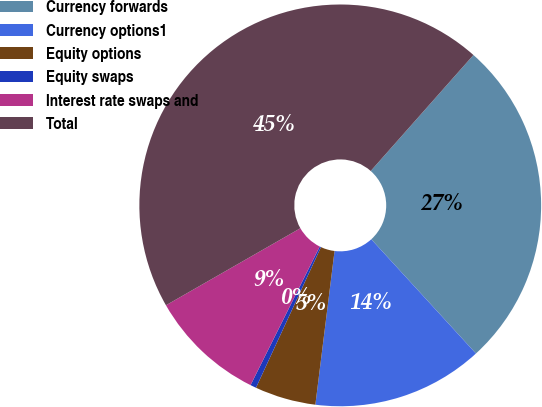Convert chart to OTSL. <chart><loc_0><loc_0><loc_500><loc_500><pie_chart><fcel>Currency forwards<fcel>Currency options1<fcel>Equity options<fcel>Equity swaps<fcel>Interest rate swaps and<fcel>Total<nl><fcel>26.66%<fcel>13.78%<fcel>4.91%<fcel>0.48%<fcel>9.35%<fcel>44.82%<nl></chart> 